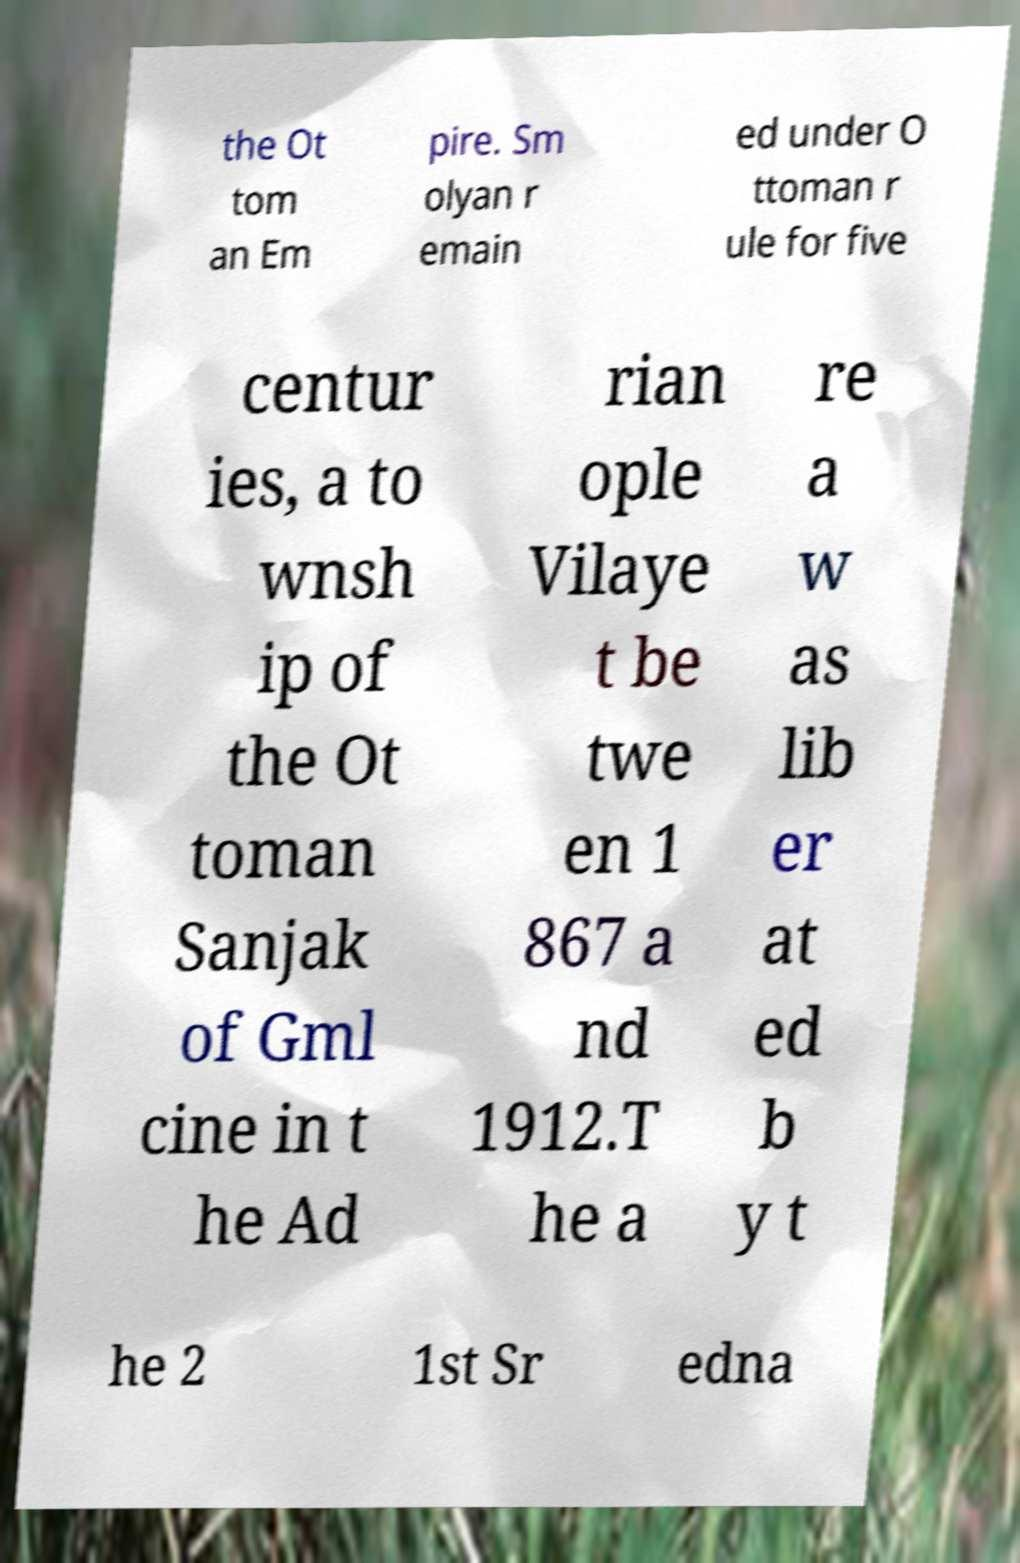Could you assist in decoding the text presented in this image and type it out clearly? the Ot tom an Em pire. Sm olyan r emain ed under O ttoman r ule for five centur ies, a to wnsh ip of the Ot toman Sanjak of Gml cine in t he Ad rian ople Vilaye t be twe en 1 867 a nd 1912.T he a re a w as lib er at ed b y t he 2 1st Sr edna 